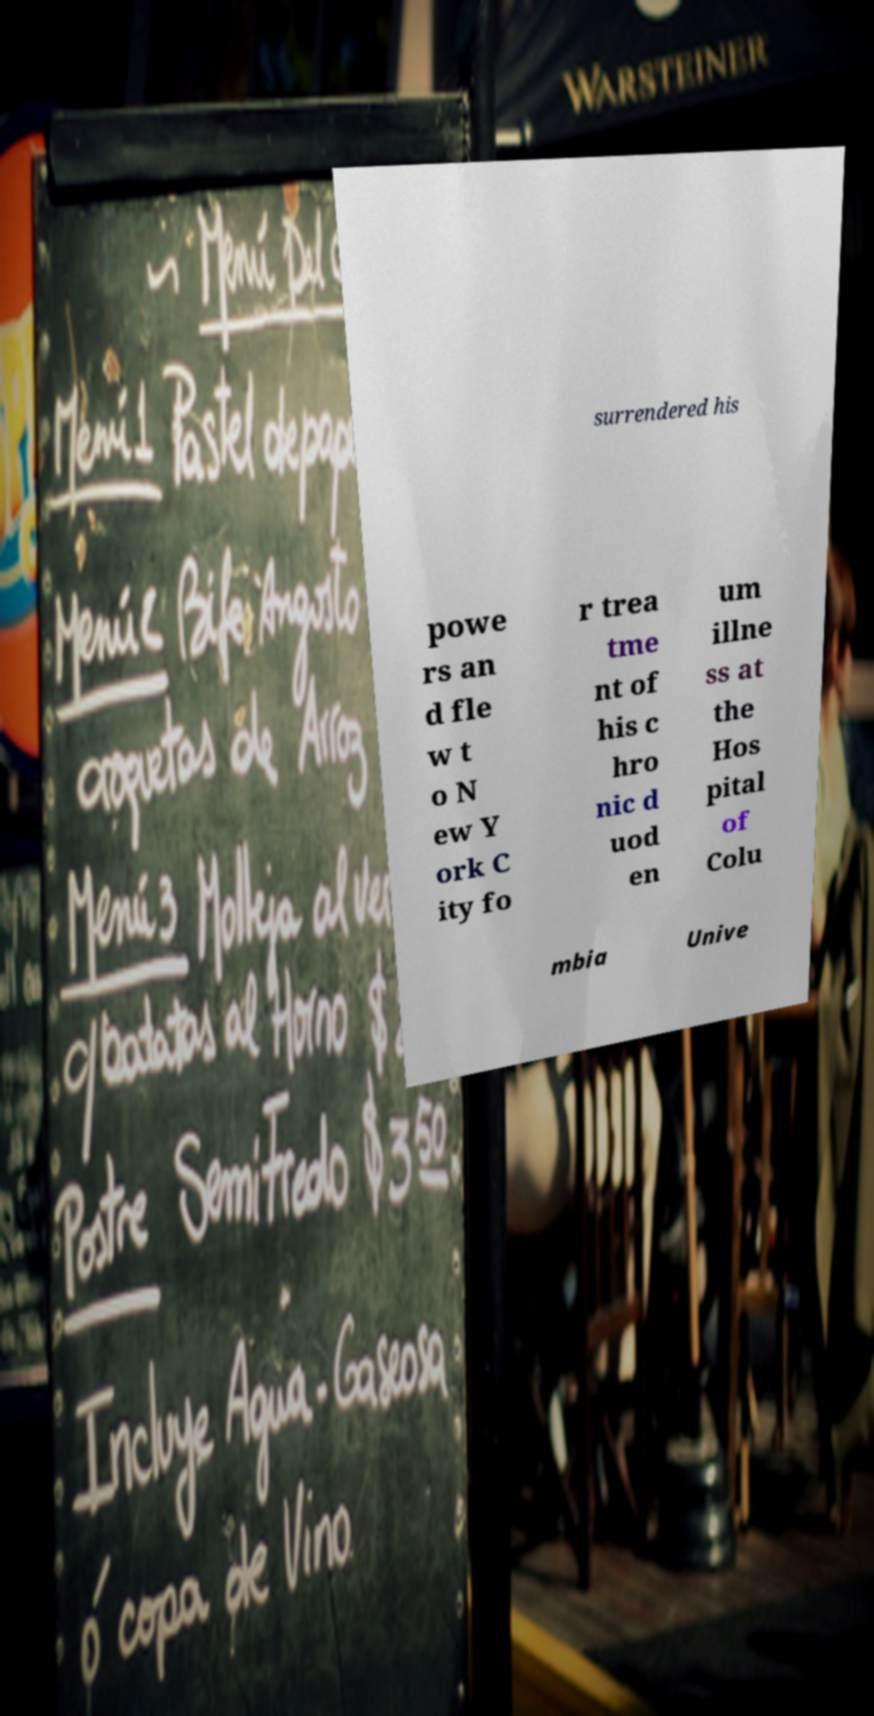Could you extract and type out the text from this image? surrendered his powe rs an d fle w t o N ew Y ork C ity fo r trea tme nt of his c hro nic d uod en um illne ss at the Hos pital of Colu mbia Unive 